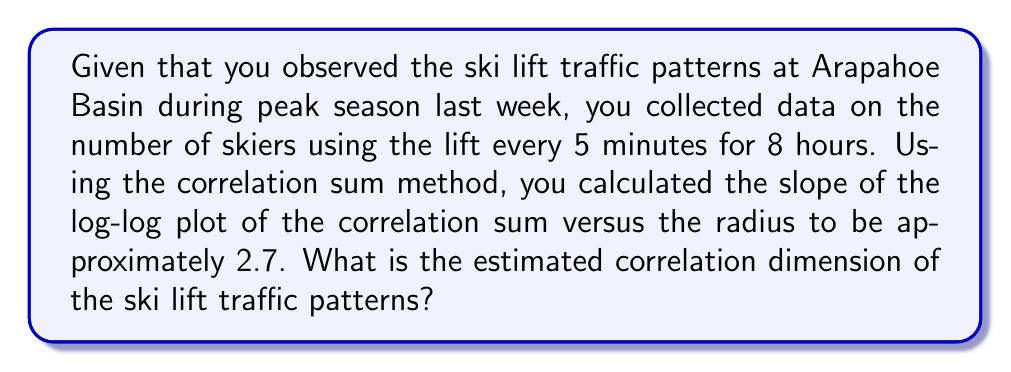Show me your answer to this math problem. To determine the correlation dimension of the ski lift traffic patterns, we need to follow these steps:

1. Understand the correlation dimension:
   The correlation dimension is a measure of the dimensionality of the space occupied by a set of random points, often used in analyzing chaotic systems.

2. Recall the relationship between the correlation sum and radius:
   In the correlation sum method, we have:
   $$C(r) \propto r^D$$
   where $C(r)$ is the correlation sum, $r$ is the radius, and $D$ is the correlation dimension.

3. Apply logarithms to linearize the relationship:
   $$\log(C(r)) \propto D \log(r)$$

4. Interpret the slope of the log-log plot:
   The slope of the log-log plot of $C(r)$ versus $r$ gives us the correlation dimension $D$.

5. Use the given information:
   The slope of the log-log plot is approximately 2.7.

6. Conclude:
   Since the slope of the log-log plot directly represents the correlation dimension, we can conclude that the estimated correlation dimension of the ski lift traffic patterns is 2.7.

This non-integer dimension suggests that the ski lift traffic patterns exhibit fractal-like behavior, which is common in complex systems with many interacting factors, such as weather conditions, time of day, and skier preferences.
Answer: 2.7 